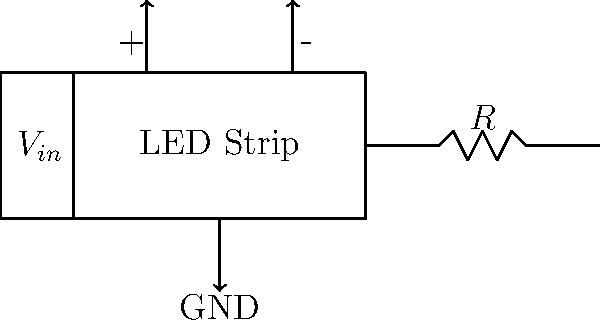As a small grocer promoting local produce, you want to design an efficient LED lighting system for your produce displays. Given the circuit diagram, what value of resistor $R$ should be used to limit the current through the LED strip to 500 mA if the input voltage $V_{in}$ is 12V and the LED strip has a forward voltage drop of 9V? To determine the appropriate resistor value, we'll follow these steps:

1. Identify the voltage across the resistor:
   $V_R = V_{in} - V_{LED}$
   $V_R = 12V - 9V = 3V$

2. Use Ohm's Law to calculate the resistor value:
   $R = \frac{V_R}{I}$
   Where $I$ is the desired current (500 mA = 0.5A)

3. Substitute the values:
   $R = \frac{3V}{0.5A} = 6\Omega$

4. Choose the nearest standard resistor value, which is 6.8Ω.

5. Verify the power rating:
   $P = I^2 * R = (0.5A)^2 * 6.8\Omega = 1.7W$
   Choose a resistor with a power rating of at least 2W for safety.
Answer: 6.8Ω, 2W 